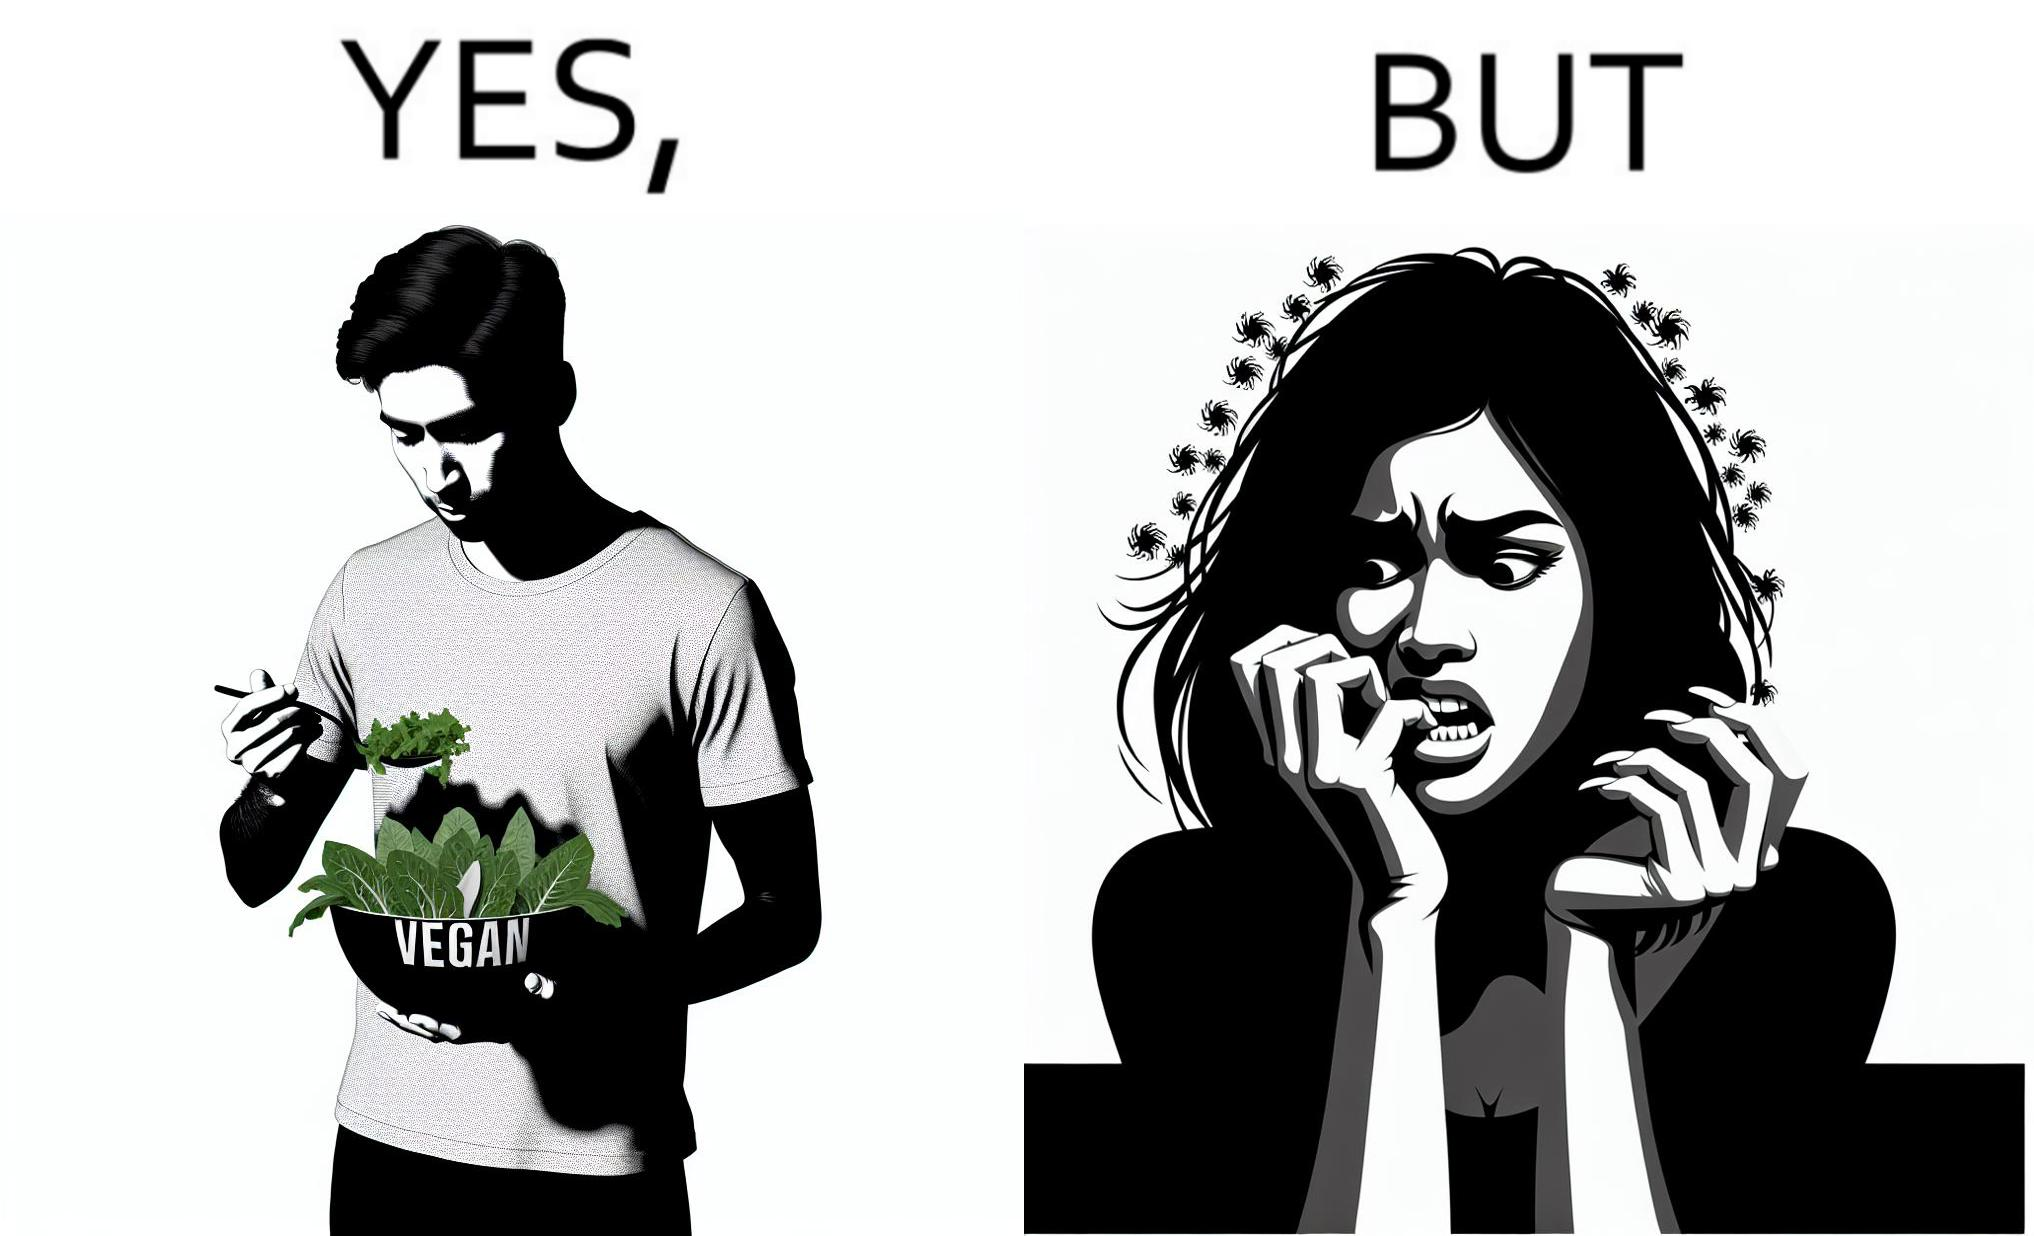What do you see in each half of this image? In the left part of the image: The image shows a man eating leafy vegetables out of a bowl in his hand. He is also wearing a t-shirt that says vegan. In the right part of the image: The image shows a person biting the skin around the fingernails of thier hand. 